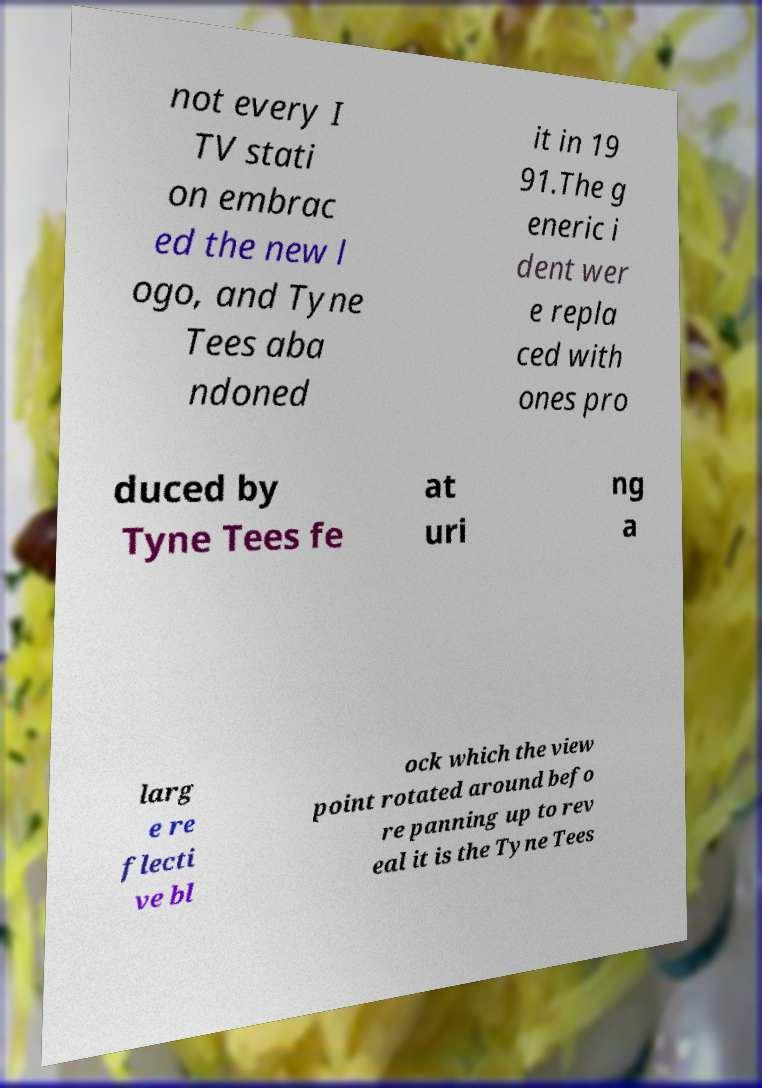Could you assist in decoding the text presented in this image and type it out clearly? not every I TV stati on embrac ed the new l ogo, and Tyne Tees aba ndoned it in 19 91.The g eneric i dent wer e repla ced with ones pro duced by Tyne Tees fe at uri ng a larg e re flecti ve bl ock which the view point rotated around befo re panning up to rev eal it is the Tyne Tees 